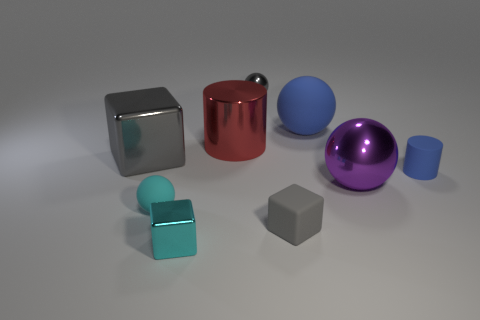What shape is the large thing that is the same color as the small rubber cube?
Your answer should be compact. Cube. What number of blue cylinders have the same size as the gray rubber thing?
Ensure brevity in your answer.  1. Does the red thing have the same shape as the tiny gray rubber object?
Offer a terse response. No. What is the color of the object on the left side of the ball that is in front of the big metal ball?
Your answer should be compact. Gray. There is a gray thing that is both to the left of the tiny gray cube and on the right side of the big metal cylinder; what size is it?
Offer a terse response. Small. Is there anything else of the same color as the matte cylinder?
Keep it short and to the point. Yes. The tiny gray thing that is the same material as the red cylinder is what shape?
Keep it short and to the point. Sphere. Do the big purple object and the gray thing on the left side of the red object have the same shape?
Provide a short and direct response. No. What material is the gray cube that is on the right side of the cylinder that is to the left of the small blue rubber thing?
Your response must be concise. Rubber. Are there the same number of spheres in front of the big gray metal object and blue cylinders?
Provide a short and direct response. No. 